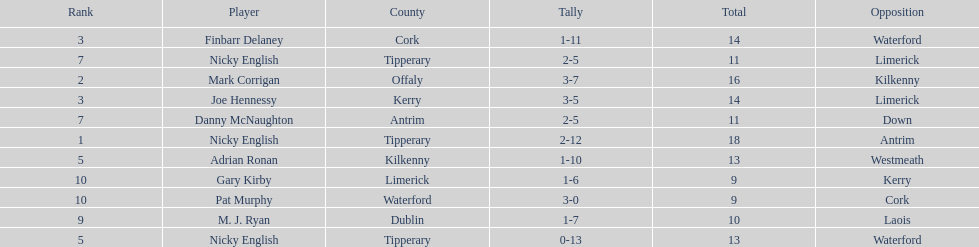Joe hennessy and finbarr delaney both scored how many points? 14. 